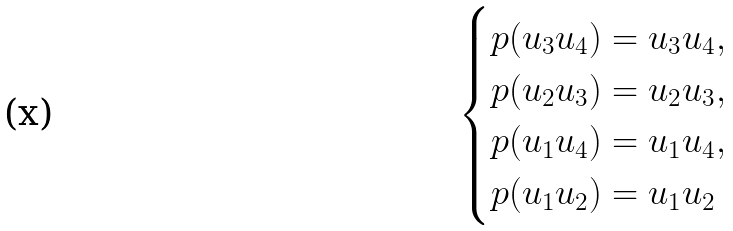<formula> <loc_0><loc_0><loc_500><loc_500>\begin{cases} p ( u _ { 3 } u _ { 4 } ) = u _ { 3 } u _ { 4 } , \\ p ( u _ { 2 } u _ { 3 } ) = u _ { 2 } u _ { 3 } , \\ p ( u _ { 1 } u _ { 4 } ) = u _ { 1 } u _ { 4 } , \\ p ( u _ { 1 } u _ { 2 } ) = u _ { 1 } u _ { 2 } \end{cases}</formula> 